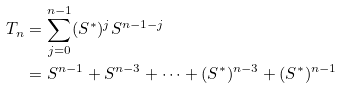<formula> <loc_0><loc_0><loc_500><loc_500>T _ { n } & = \sum _ { j = 0 } ^ { n - 1 } ( S ^ { * } ) ^ { j } S ^ { n - 1 - j } \\ & = S ^ { n - 1 } + S ^ { n - 3 } + \cdots + ( S ^ { * } ) ^ { n - 3 } + ( S ^ { * } ) ^ { n - 1 }</formula> 